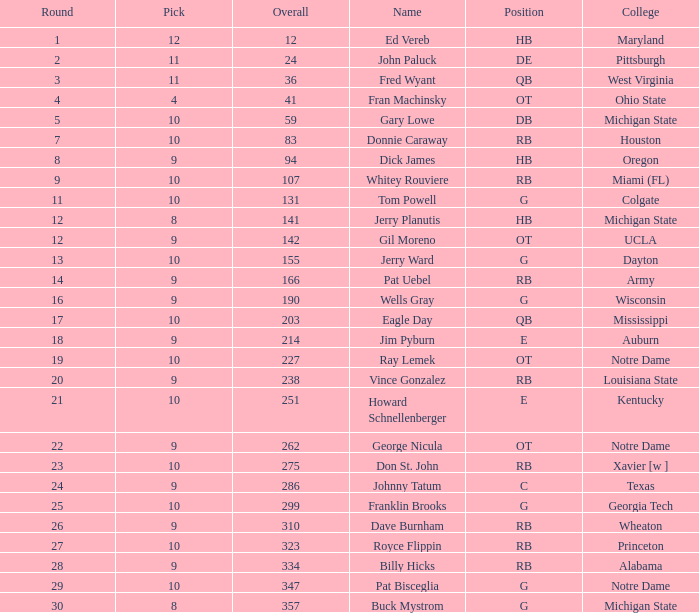What is the highest overall pick number for george nicula who had a pick smaller than 9? None. Can you give me this table as a dict? {'header': ['Round', 'Pick', 'Overall', 'Name', 'Position', 'College'], 'rows': [['1', '12', '12', 'Ed Vereb', 'HB', 'Maryland'], ['2', '11', '24', 'John Paluck', 'DE', 'Pittsburgh'], ['3', '11', '36', 'Fred Wyant', 'QB', 'West Virginia'], ['4', '4', '41', 'Fran Machinsky', 'OT', 'Ohio State'], ['5', '10', '59', 'Gary Lowe', 'DB', 'Michigan State'], ['7', '10', '83', 'Donnie Caraway', 'RB', 'Houston'], ['8', '9', '94', 'Dick James', 'HB', 'Oregon'], ['9', '10', '107', 'Whitey Rouviere', 'RB', 'Miami (FL)'], ['11', '10', '131', 'Tom Powell', 'G', 'Colgate'], ['12', '8', '141', 'Jerry Planutis', 'HB', 'Michigan State'], ['12', '9', '142', 'Gil Moreno', 'OT', 'UCLA'], ['13', '10', '155', 'Jerry Ward', 'G', 'Dayton'], ['14', '9', '166', 'Pat Uebel', 'RB', 'Army'], ['16', '9', '190', 'Wells Gray', 'G', 'Wisconsin'], ['17', '10', '203', 'Eagle Day', 'QB', 'Mississippi'], ['18', '9', '214', 'Jim Pyburn', 'E', 'Auburn'], ['19', '10', '227', 'Ray Lemek', 'OT', 'Notre Dame'], ['20', '9', '238', 'Vince Gonzalez', 'RB', 'Louisiana State'], ['21', '10', '251', 'Howard Schnellenberger', 'E', 'Kentucky'], ['22', '9', '262', 'George Nicula', 'OT', 'Notre Dame'], ['23', '10', '275', 'Don St. John', 'RB', 'Xavier [w ]'], ['24', '9', '286', 'Johnny Tatum', 'C', 'Texas'], ['25', '10', '299', 'Franklin Brooks', 'G', 'Georgia Tech'], ['26', '9', '310', 'Dave Burnham', 'RB', 'Wheaton'], ['27', '10', '323', 'Royce Flippin', 'RB', 'Princeton'], ['28', '9', '334', 'Billy Hicks', 'RB', 'Alabama'], ['29', '10', '347', 'Pat Bisceglia', 'G', 'Notre Dame'], ['30', '8', '357', 'Buck Mystrom', 'G', 'Michigan State']]} 